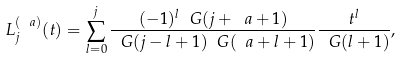<formula> <loc_0><loc_0><loc_500><loc_500>L _ { j } ^ { ( \ a ) } ( t ) = \sum _ { l = 0 } ^ { j } \frac { ( - 1 ) ^ { l } \ G ( j + \ a + 1 ) } { \ G ( j - l + 1 ) \ G ( \ a + l + 1 ) } \frac { t ^ { l } } { \ G ( l + 1 ) } ,</formula> 